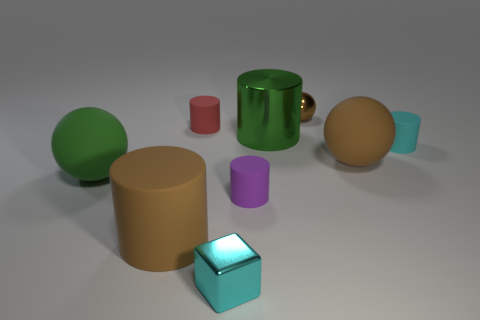The red rubber object that is the same size as the cyan block is what shape?
Give a very brief answer. Cylinder. Is the small metallic block the same color as the tiny ball?
Offer a terse response. No. What is the color of the object on the right side of the brown matte object to the right of the brown object that is on the left side of the red rubber thing?
Give a very brief answer. Cyan. What is the size of the green metallic thing that is the same shape as the red thing?
Offer a terse response. Large. There is a tiny object to the right of the sphere that is right of the brown metallic object; what color is it?
Provide a short and direct response. Cyan. How many other things are the same material as the small red object?
Provide a short and direct response. 5. How many large cylinders are behind the green object left of the shiny cylinder?
Your answer should be compact. 1. Is there anything else that has the same shape as the purple matte object?
Make the answer very short. Yes. Do the tiny matte cylinder that is right of the small purple matte thing and the big thing to the right of the small brown ball have the same color?
Provide a succinct answer. No. Is the number of cyan objects less than the number of big green spheres?
Your answer should be compact. No. 